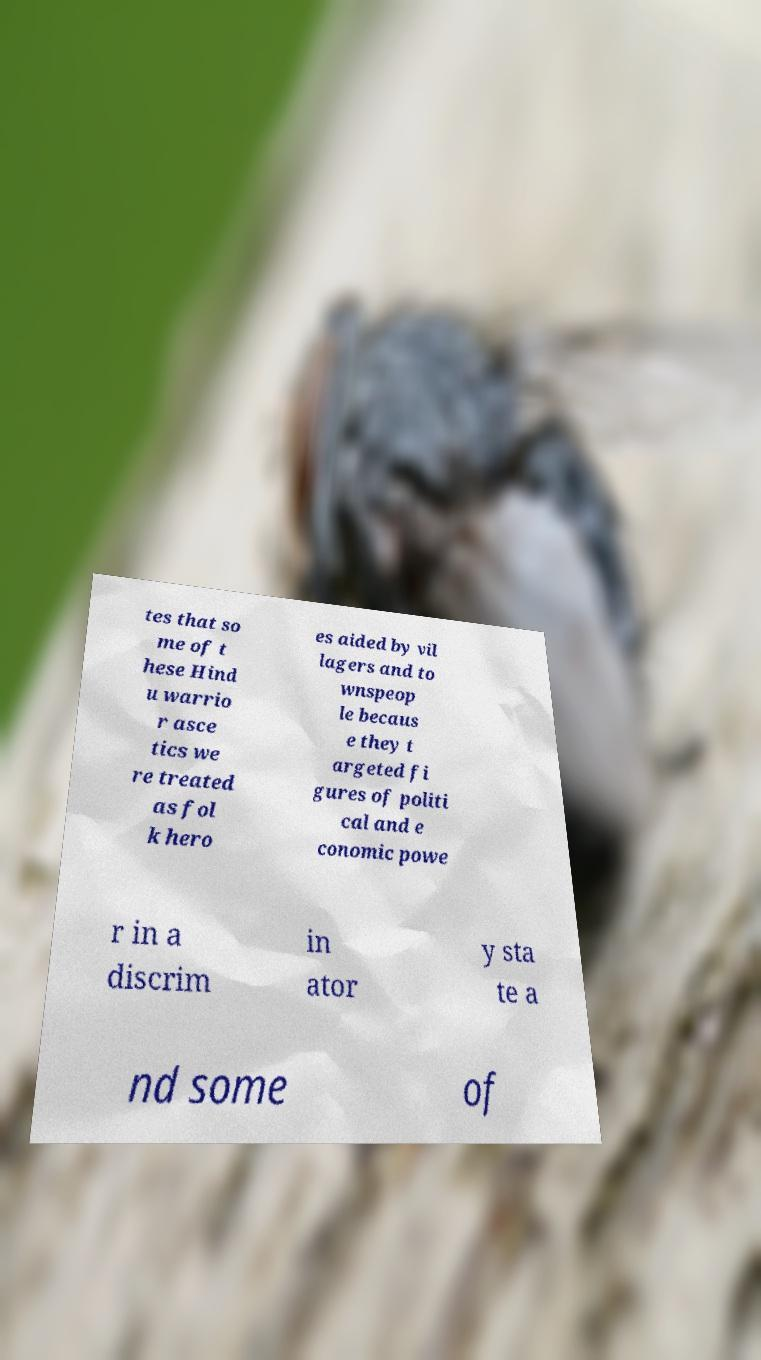Could you extract and type out the text from this image? tes that so me of t hese Hind u warrio r asce tics we re treated as fol k hero es aided by vil lagers and to wnspeop le becaus e they t argeted fi gures of politi cal and e conomic powe r in a discrim in ator y sta te a nd some of 